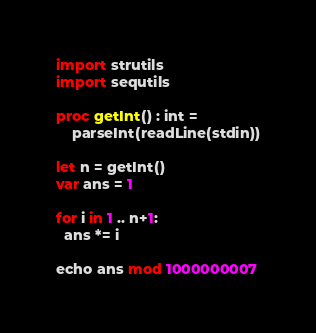Convert code to text. <code><loc_0><loc_0><loc_500><loc_500><_Nim_>import strutils
import sequtils

proc getInt() : int =
    parseInt(readLine(stdin))

let n = getInt()
var ans = 1

for i in 1 .. n+1:
  ans *= i

echo ans mod 1000000007</code> 